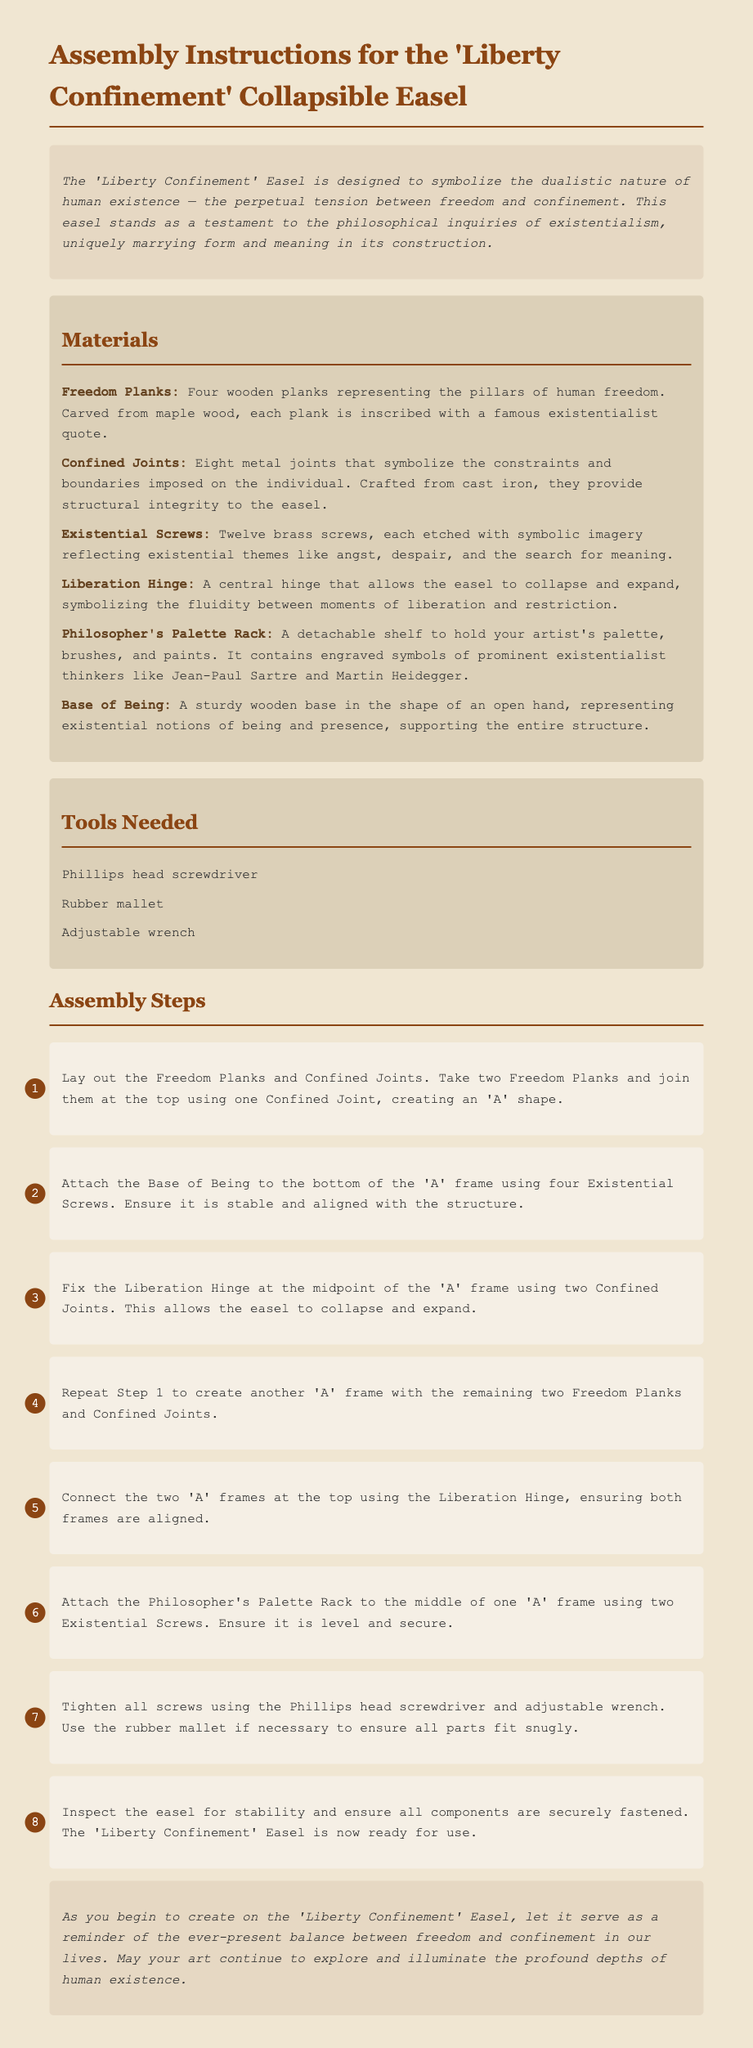What is the name of the easel? The title of the easel is provided in the document's header, emphasizing its theme of freedom and confinement.
Answer: Liberty Confinement How many Freedom Planks are needed? The materials section specifies the number of Freedom Planks required for assembly.
Answer: Four What type of wood is used for the Freedom Planks? The document describes the materials, including the type of wood used for the Freedom Planks.
Answer: Maple wood How many Existential Screws are included? The materials list quantifies the Existential Screws necessary for the easel's construction.
Answer: Twelve What is the shape of the Base of Being? The document describes the design of the Base of Being, highlighting its symbolic representation.
Answer: Open hand What tool is needed to tighten screws? The tools section mentions the specific tool required for tightening the screws during assembly.
Answer: Phillips head screwdriver What does the Liberation Hinge symbolize? The introduction and materials section explain the symbolic meaning of the Liberation Hinge in the context of the easel.
Answer: Fluidity between liberation and restriction How many steps are included in the assembly instructions? By counting each step outlined in the assembly steps section, we can identify the total number of steps required.
Answer: Eight What is the purpose of the Philosopher's Palette Rack? The document explains the role of the Philosopher's Palette Rack in supporting artistic tools and symbols.
Answer: Hold artist's palette, brushes, and paints 